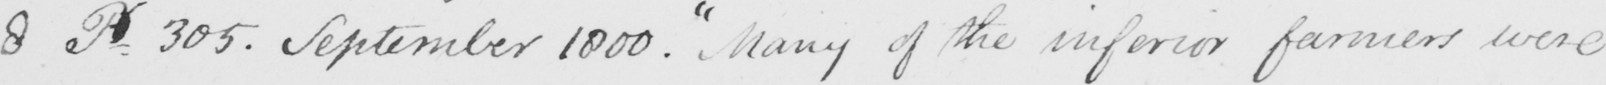Transcribe the text shown in this historical manuscript line. 8 P.305 . September 1800 .  " Many of the inferior farmers were 